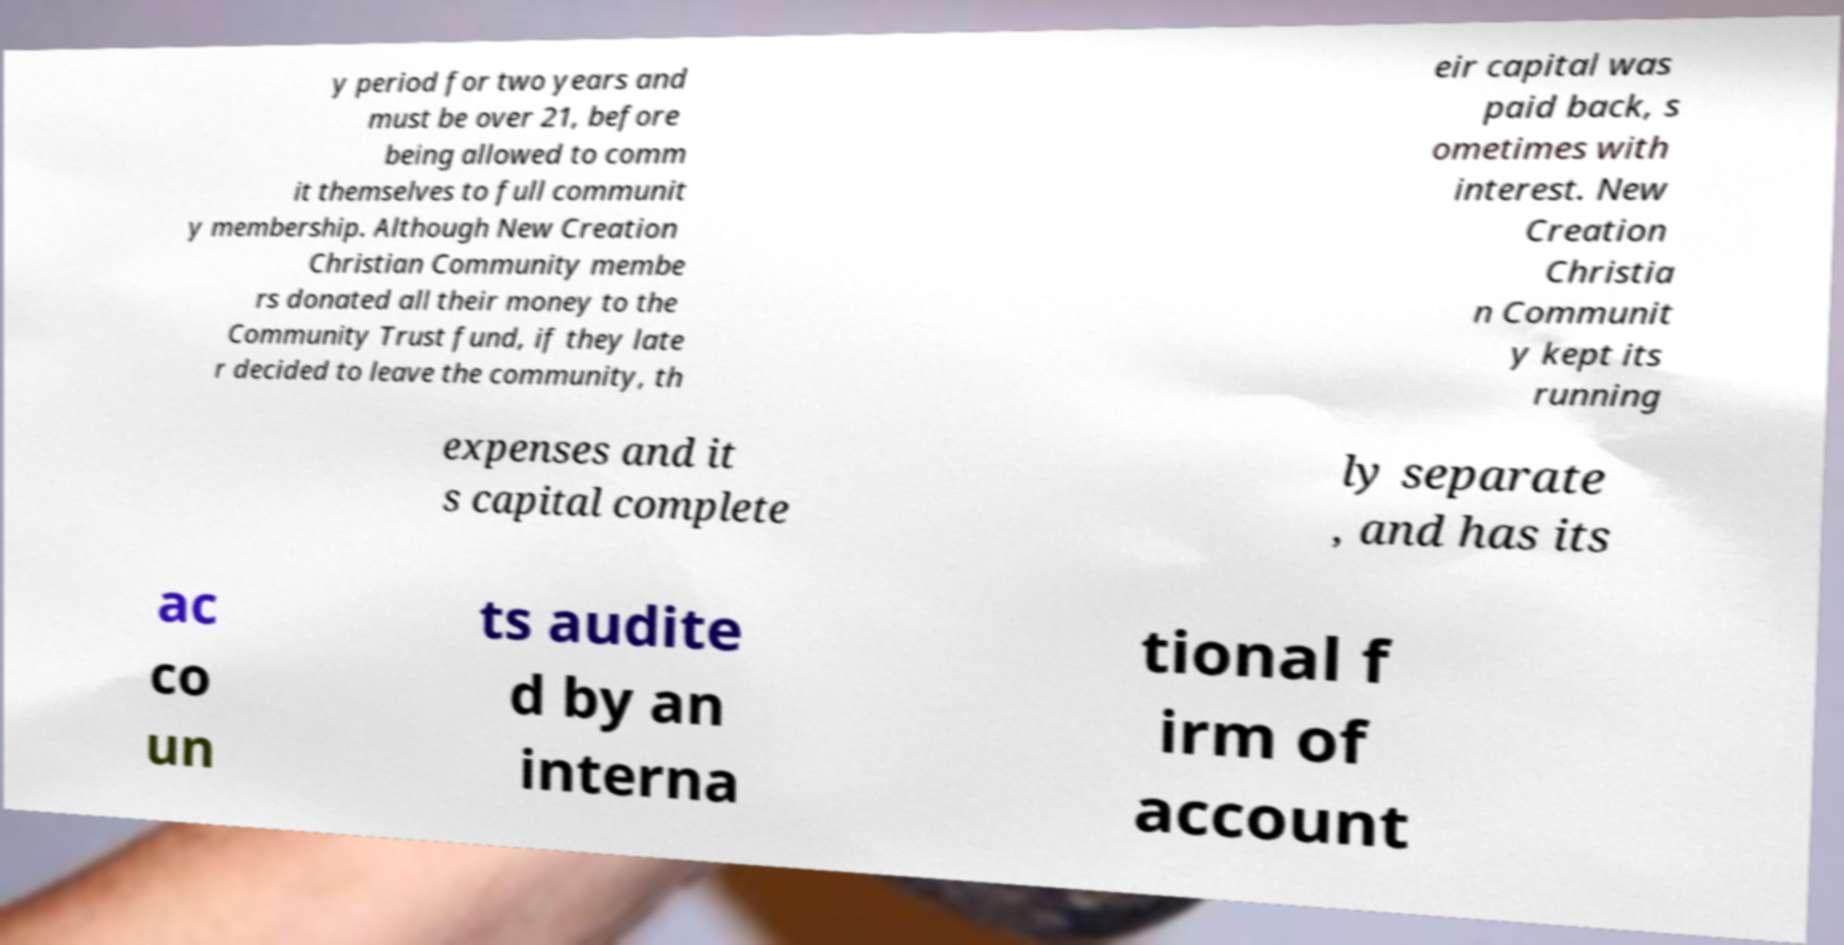Could you extract and type out the text from this image? y period for two years and must be over 21, before being allowed to comm it themselves to full communit y membership. Although New Creation Christian Community membe rs donated all their money to the Community Trust fund, if they late r decided to leave the community, th eir capital was paid back, s ometimes with interest. New Creation Christia n Communit y kept its running expenses and it s capital complete ly separate , and has its ac co un ts audite d by an interna tional f irm of account 